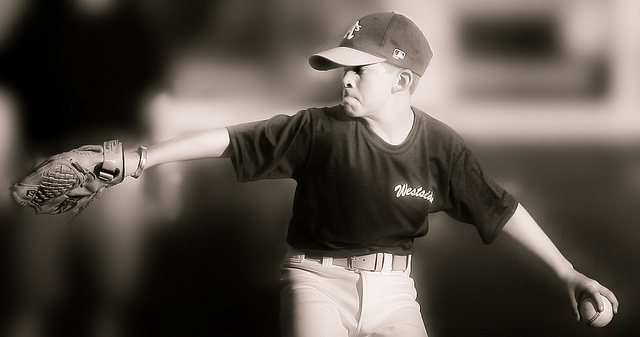Describe the objects in this image and their specific colors. I can see people in gray, black, lightgray, and darkgray tones, baseball glove in gray, black, and darkgray tones, and sports ball in gray, black, lightgray, and darkgray tones in this image. 